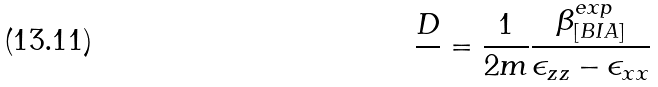Convert formula to latex. <formula><loc_0><loc_0><loc_500><loc_500>\frac { D } { } = \frac { 1 } { 2 m } \frac { \beta _ { [ B I A ] } ^ { e x p } } { \epsilon _ { z z } - \epsilon _ { x x } }</formula> 